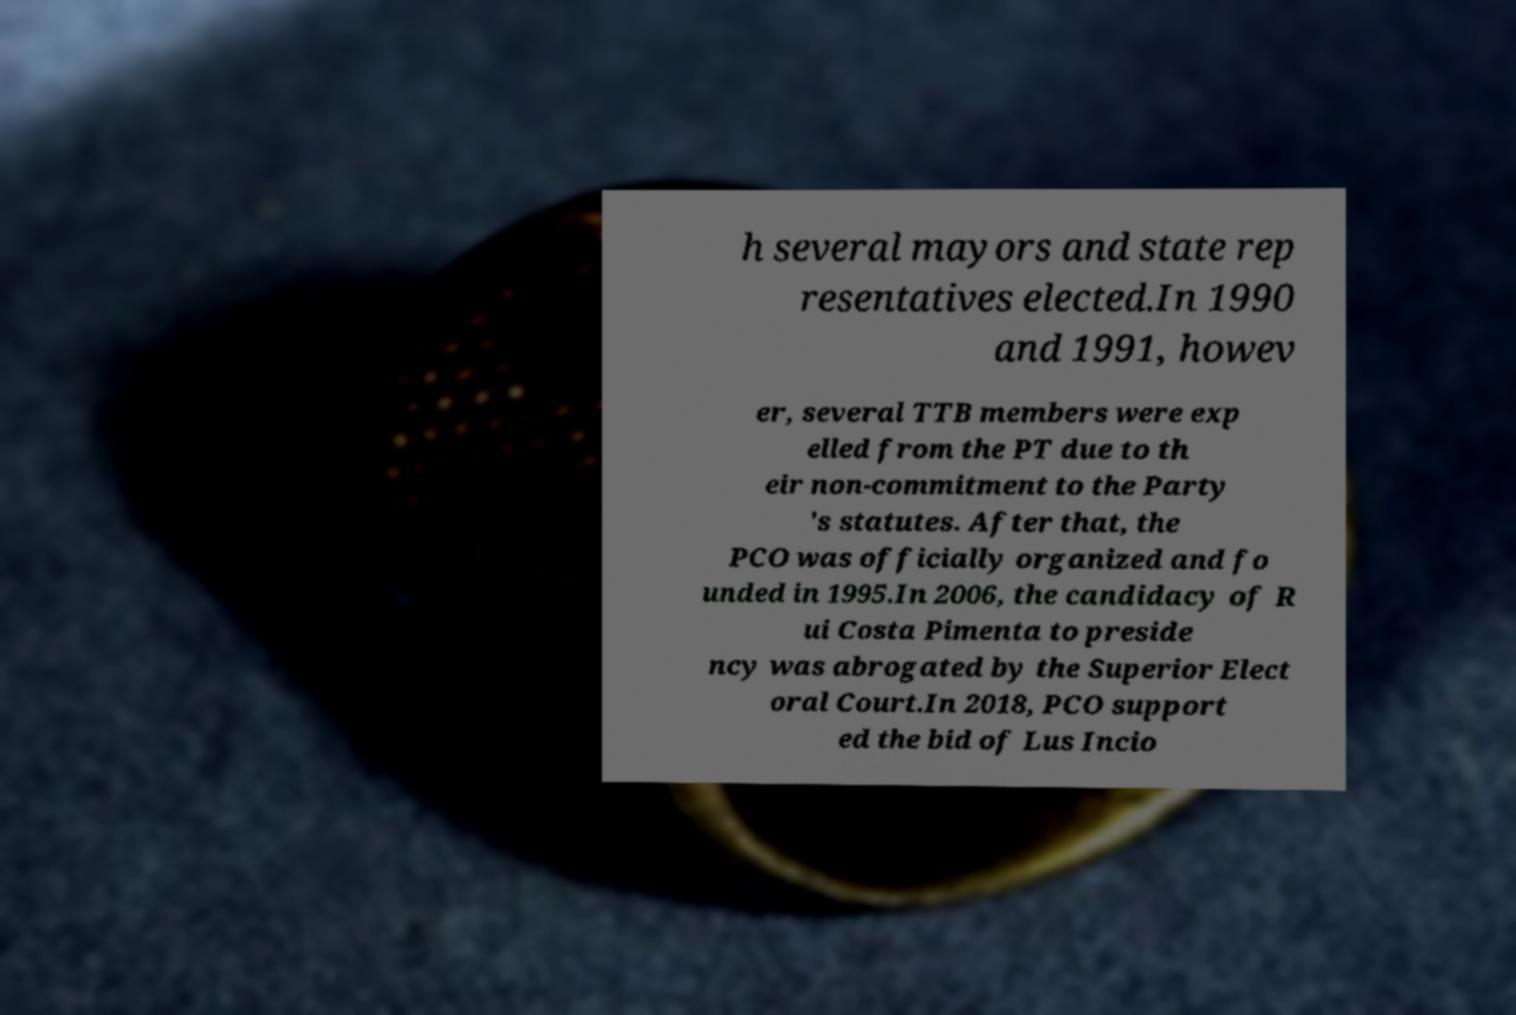Could you assist in decoding the text presented in this image and type it out clearly? h several mayors and state rep resentatives elected.In 1990 and 1991, howev er, several TTB members were exp elled from the PT due to th eir non-commitment to the Party 's statutes. After that, the PCO was officially organized and fo unded in 1995.In 2006, the candidacy of R ui Costa Pimenta to preside ncy was abrogated by the Superior Elect oral Court.In 2018, PCO support ed the bid of Lus Incio 